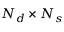<formula> <loc_0><loc_0><loc_500><loc_500>N _ { d } \times N _ { s }</formula> 